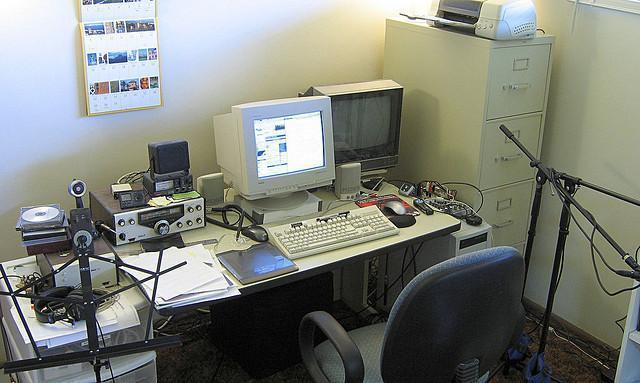How many tvs are there?
Give a very brief answer. 2. How many people are laying down?
Give a very brief answer. 0. 